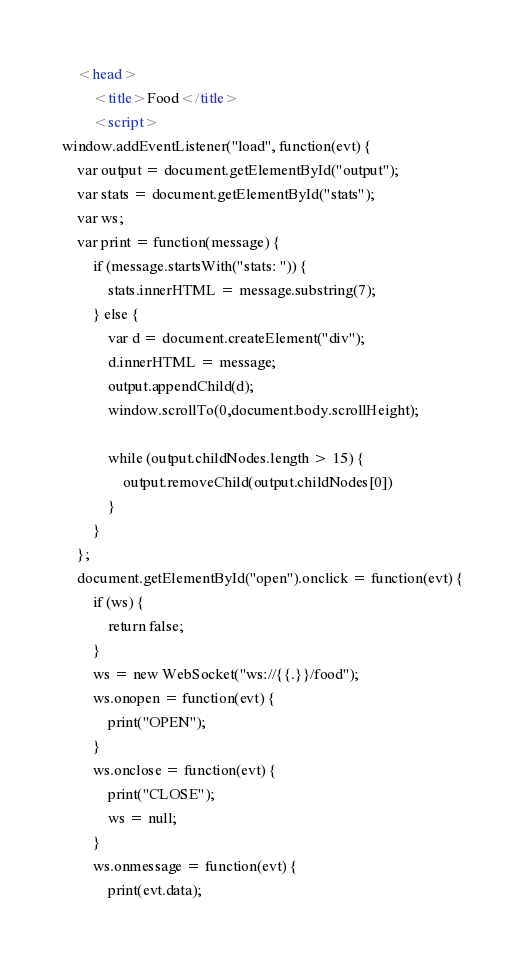Convert code to text. <code><loc_0><loc_0><loc_500><loc_500><_HTML_>	<head>
		<title>Food</title>
		<script>  
window.addEventListener("load", function(evt) {
    var output = document.getElementById("output");
    var stats = document.getElementById("stats");
    var ws;
    var print = function(message) {
        if (message.startsWith("stats: ")) {
            stats.innerHTML = message.substring(7);
        } else {
            var d = document.createElement("div");
            d.innerHTML = message;
            output.appendChild(d);
            window.scrollTo(0,document.body.scrollHeight);

            while (output.childNodes.length > 15) {
                output.removeChild(output.childNodes[0]) 
            }
        }
    };
    document.getElementById("open").onclick = function(evt) {
        if (ws) {
            return false;
        }
        ws = new WebSocket("ws://{{.}}/food");
        ws.onopen = function(evt) {
            print("OPEN");
        }
        ws.onclose = function(evt) {
            print("CLOSE");
            ws = null;
        }
        ws.onmessage = function(evt) {
            print(evt.data);</code> 